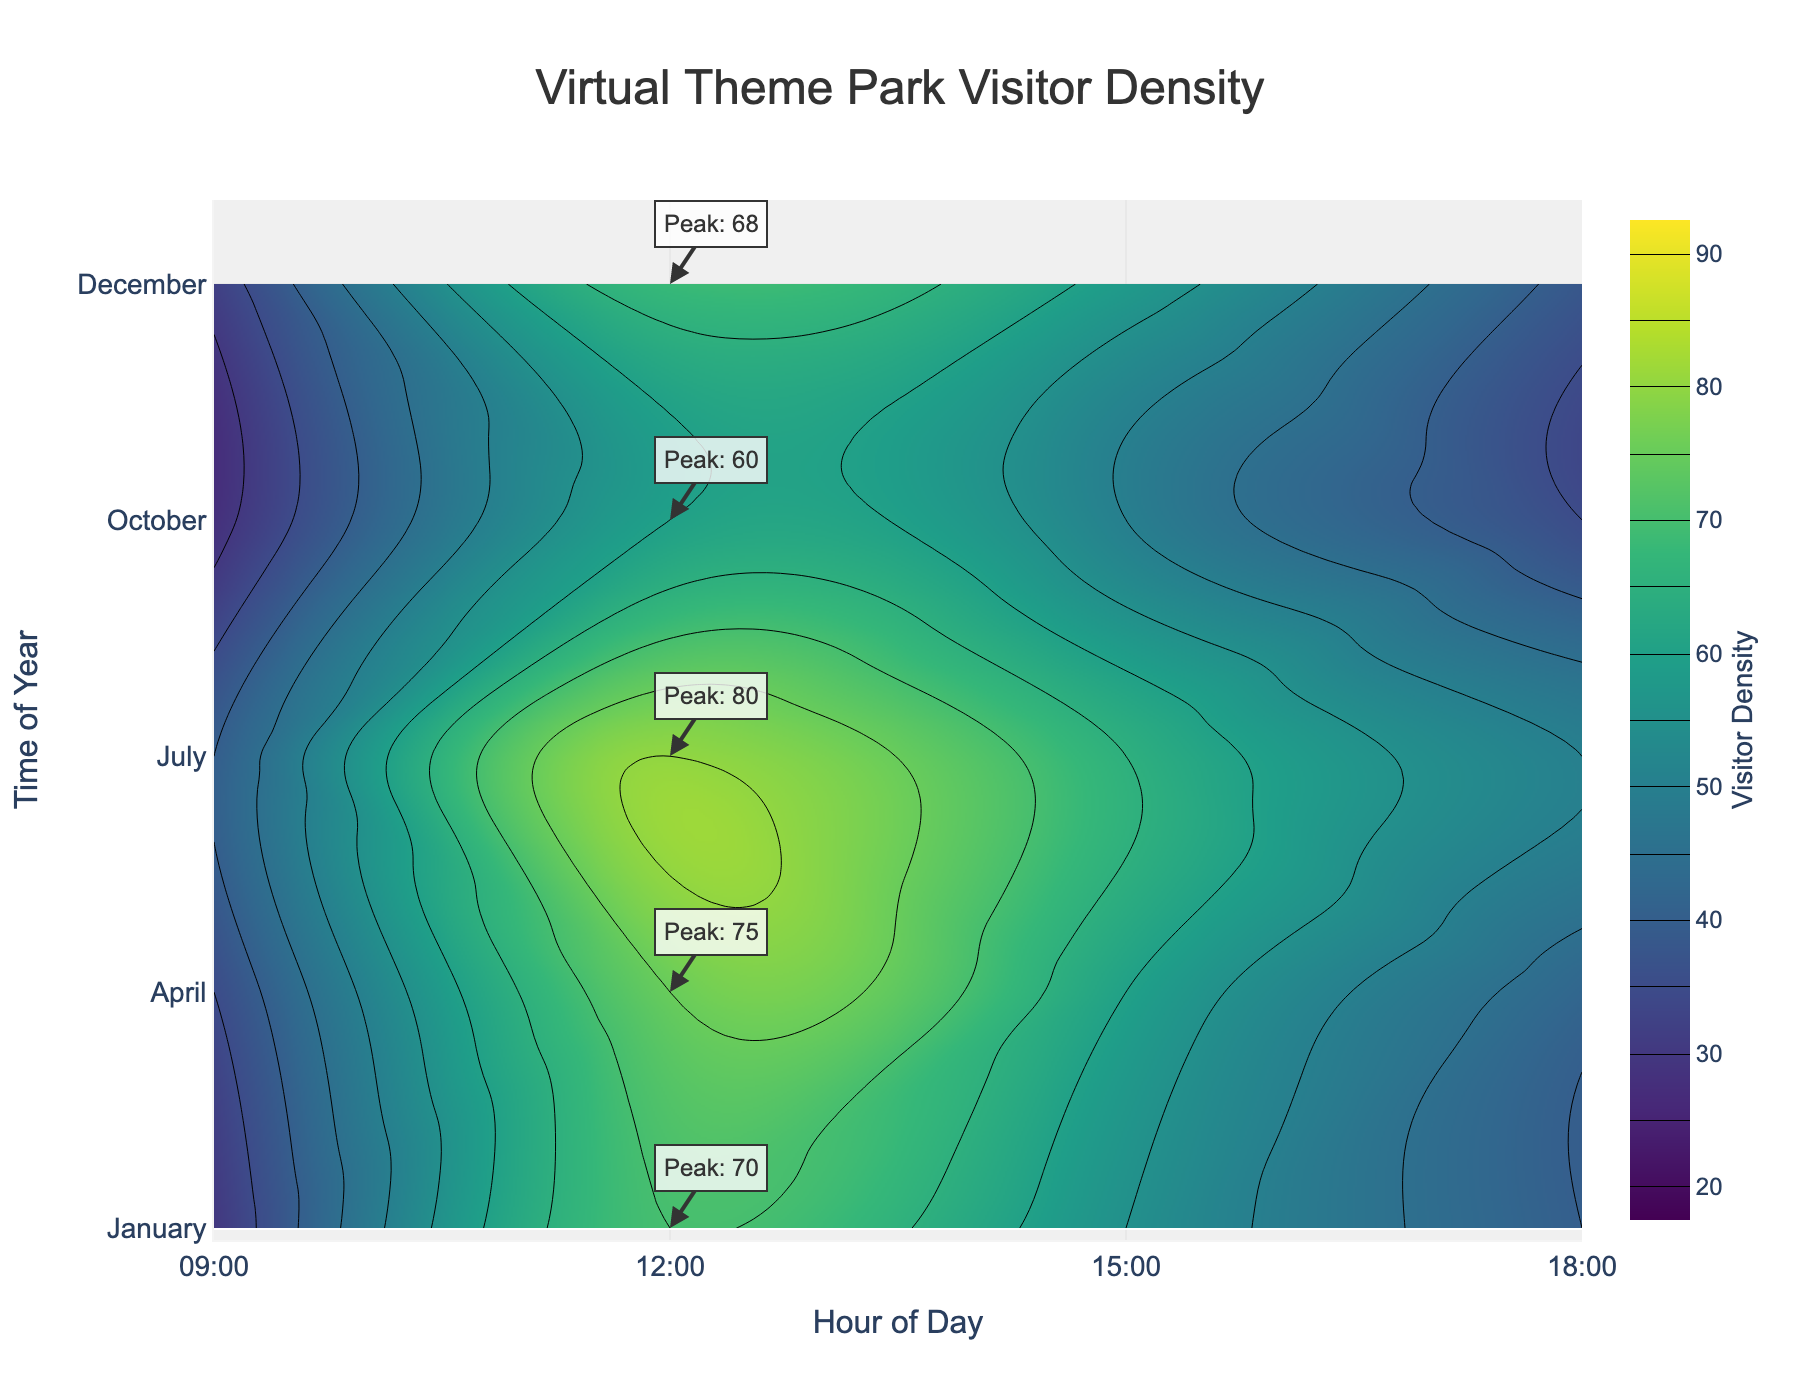What's the title of the figure? Look at the top of the figure where the title is displayed prominently. It should give a clear indication of what the plot represents.
Answer: Virtual Theme Park Visitor Density What are the axis labels? The axis labels are text descriptions next to the horizontal and vertical lines (axes) in the plot that indicate what each axis represents.
Answer: Hour of Day (x-axis) and Time of Year (y-axis) Which time of day has the highest visitor density in July? Check the contour lines intersecting with the "July" label on the y-axis and find the peak value within that section. The peak will be annotated or visually evident.
Answer: 12:00 In which month is the visitor density the lowest at 9 AM? Look at the contour lines or annotations at the 9 AM mark along the x-axis and identify the lowest density value across different months labeled on the y-axis.
Answer: October Compare the visitor density at 3 PM between January and October. Which one has a higher visitor density? Locate 3 PM on the x-axis and compare the density values across the contour lines intersecting with January and October on the y-axis.
Answer: January What's the peak visitor density in December? Identify the peak visitor density annotation or the highest contour intersection within the December section on the y-axis.
Answer: 68 Which month shows the most consistent visitor density throughout the day? Analyze the contour variations across the hours for each month. A month with less drastic changes in density values is the most consistent.
Answer: April Calculate the average peak visitor density across all months shown. Gather the peak densities from annotations or highest contour intersections for all months (70 for January, 75 for April, 80 for July, 60 for October, and 68 for December), sum them up and then divide by the number of months.
Answer: 71 What is the visitor density trend from 9 AM to 6 PM in April? Follow the contour lines from the 9 AM mark to the 6 PM mark within the section labeled April and observe the changes in density values.
Answer: Increasing then slightly decreasing During which month and hour combination do visitors reach their highest density? Observe all annotations and contour peaks to determine the single highest density value and identify its corresponding month and hour.
Answer: July, 12:00 